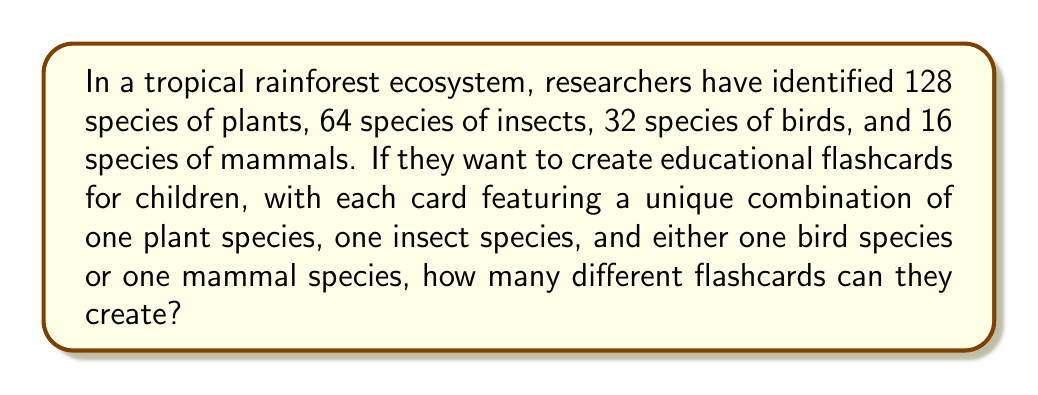Give your solution to this math problem. Let's break this problem down step by step:

1. First, we need to understand what constitutes a unique flashcard:
   - One plant species
   - One insect species
   - Either one bird species OR one mammal species

2. We can use the multiplication principle of counting for the plant and insect species:
   - Number of ways to choose a plant: 128
   - Number of ways to choose an insect: 64
   - So far, we have $128 \times 64 = 8,192$ combinations

3. For the third element, we have two mutually exclusive options:
   - Choose a bird species: 32 ways
   - Choose a mammal species: 16 ways

4. We can use the addition principle here, as it's either a bird OR a mammal:
   - Total options for the third element: $32 + 16 = 48$

5. Now, we can apply the multiplication principle again:
   - Total number of unique flashcards = (Plant options) × (Insect options) × (Bird or Mammal options)
   - $$ \text{Total flashcards} = 128 \times 64 \times 48 $$

6. Let's calculate:
   $$ \begin{aligned}
   \text{Total flashcards} &= 128 \times 64 \times 48 \\
   &= 8,192 \times 48 \\
   &= 393,216
   \end{aligned} $$

Therefore, the researchers can create 393,216 different flashcards.
Answer: 393,216 flashcards 